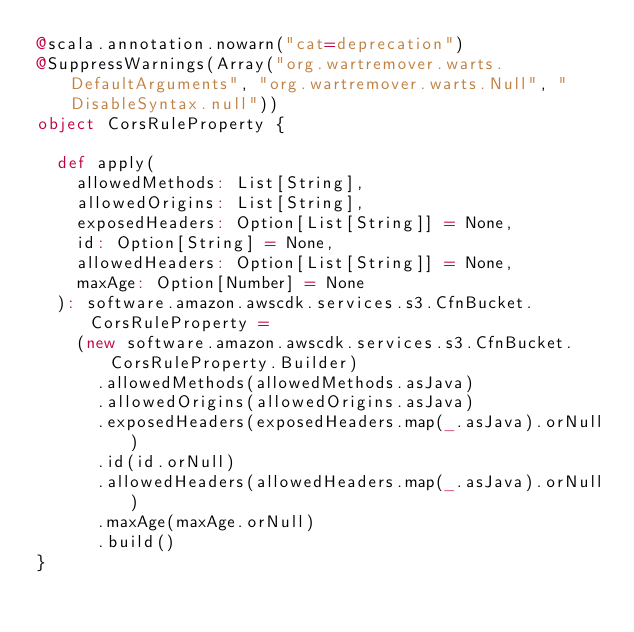<code> <loc_0><loc_0><loc_500><loc_500><_Scala_>@scala.annotation.nowarn("cat=deprecation")
@SuppressWarnings(Array("org.wartremover.warts.DefaultArguments", "org.wartremover.warts.Null", "DisableSyntax.null"))
object CorsRuleProperty {

  def apply(
    allowedMethods: List[String],
    allowedOrigins: List[String],
    exposedHeaders: Option[List[String]] = None,
    id: Option[String] = None,
    allowedHeaders: Option[List[String]] = None,
    maxAge: Option[Number] = None
  ): software.amazon.awscdk.services.s3.CfnBucket.CorsRuleProperty =
    (new software.amazon.awscdk.services.s3.CfnBucket.CorsRuleProperty.Builder)
      .allowedMethods(allowedMethods.asJava)
      .allowedOrigins(allowedOrigins.asJava)
      .exposedHeaders(exposedHeaders.map(_.asJava).orNull)
      .id(id.orNull)
      .allowedHeaders(allowedHeaders.map(_.asJava).orNull)
      .maxAge(maxAge.orNull)
      .build()
}
</code> 